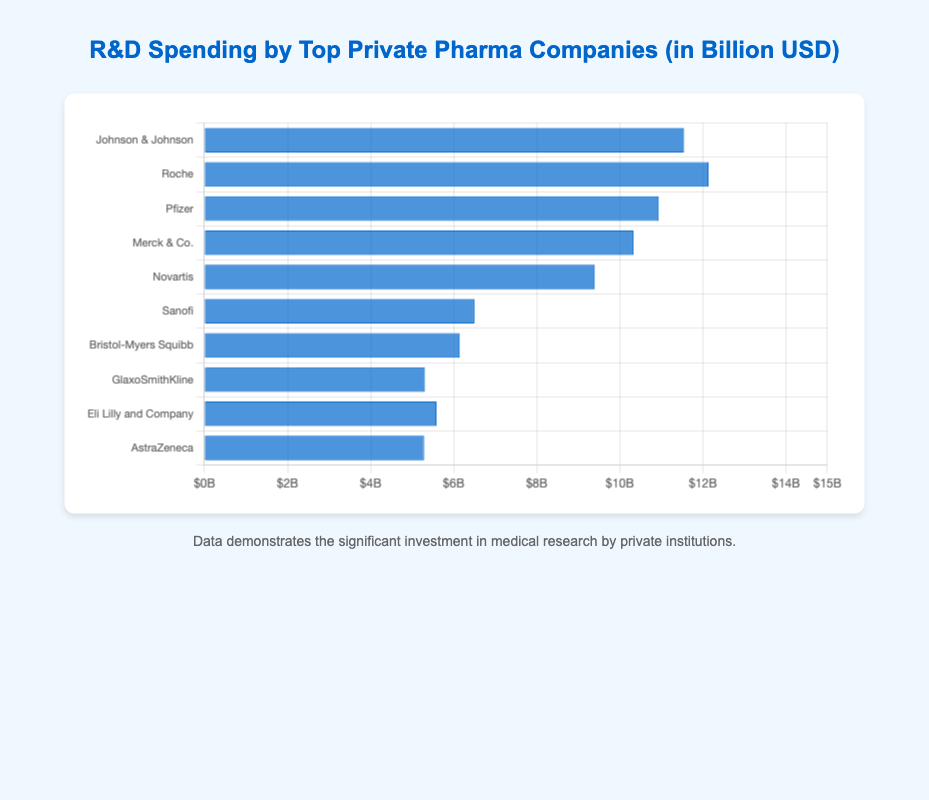Which company has the highest R&D spending? By looking at the heights of the bars, Roche has the tallest bar, indicating it has the highest R&D spending among the listed companies.
Answer: Roche Which company has the lowest R&D spending? By observing the bars, AstraZeneca's bar is the shortest, indicating it has the lowest R&D spending among the listed companies.
Answer: AstraZeneca What is the sum of the R&D spending of Johnson & Johnson and Pfizer? To find the total, we add Johnson & Johnson's spending (11.55 billion USD) to Pfizer's spending (10.94 billion USD), resulting in: 11.55 + 10.94 = 22.49 billion USD.
Answer: 22.49 Which company spends more on R&D, Merck & Co. or Novartis? By how much? We compare the two bars: Merck & Co. spends 10.33 billion USD while Novartis spends 9.40 billion USD. The difference is 10.33 - 9.40 = 0.93 billion USD.
Answer: Merck & Co., 0.93 What is the average R&D spending of the top 3 companies? The top 3 companies by R&D spending are Roche (12.14 billion USD), Johnson & Johnson (11.55 billion USD), and Pfizer (10.94 billion USD). The average is calculated as: (12.14 + 11.55 + 10.94) / 3 = 11.54 billion USD.
Answer: 11.54 Which companies spend less than 6 billion USD on R&D? By looking at the heights of the bars less than the 6-billion USD mark, GlaxoSmithKline, Eli Lilly and Company, and AstraZeneca spend less than 6 billion USD on R&D.
Answer: GlaxoSmithKline, Eli Lilly and Company, AstraZeneca How much more does Roche spend on R&D compared to Sanofi? Roche spends 12.14 billion USD, while Sanofi spends 6.50 billion USD. The difference is 12.14 - 6.50 = 5.64 billion USD.
Answer: 5.64 What is the total R&D spending of all listed companies? Summing up the R&D spending of all companies: 11.55 + 12.14 + 10.94 + 10.33 + 9.40 + 6.50 + 6.15 + 5.31 + 5.59 + 5.29 = 83.2 billion USD.
Answer: 83.2 